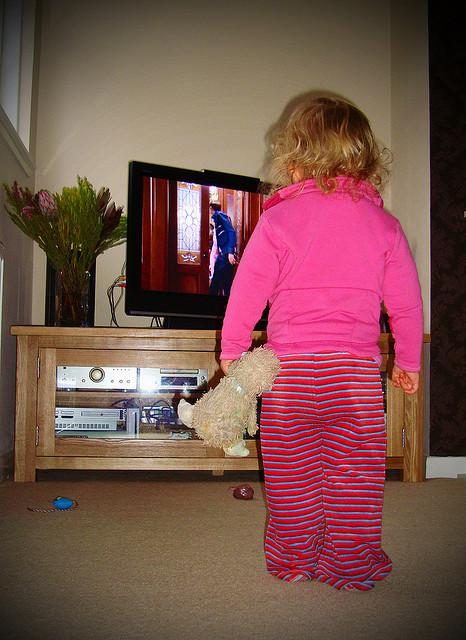What is pictured on the TV?
Write a very short answer. Show. Which hand is the teddy bear in?
Be succinct. Left. What shade of pink is the girls shirt?
Concise answer only. Dark. Is the room neat?
Concise answer only. Yes. How many kids are there?
Give a very brief answer. 1. What is the dog sitting on?
Short answer required. No dog. What is the boy watching on TV?
Concise answer only. Movie. Are her pants stripped?
Keep it brief. Yes. What is the girl looking at?
Keep it brief. Tv. 